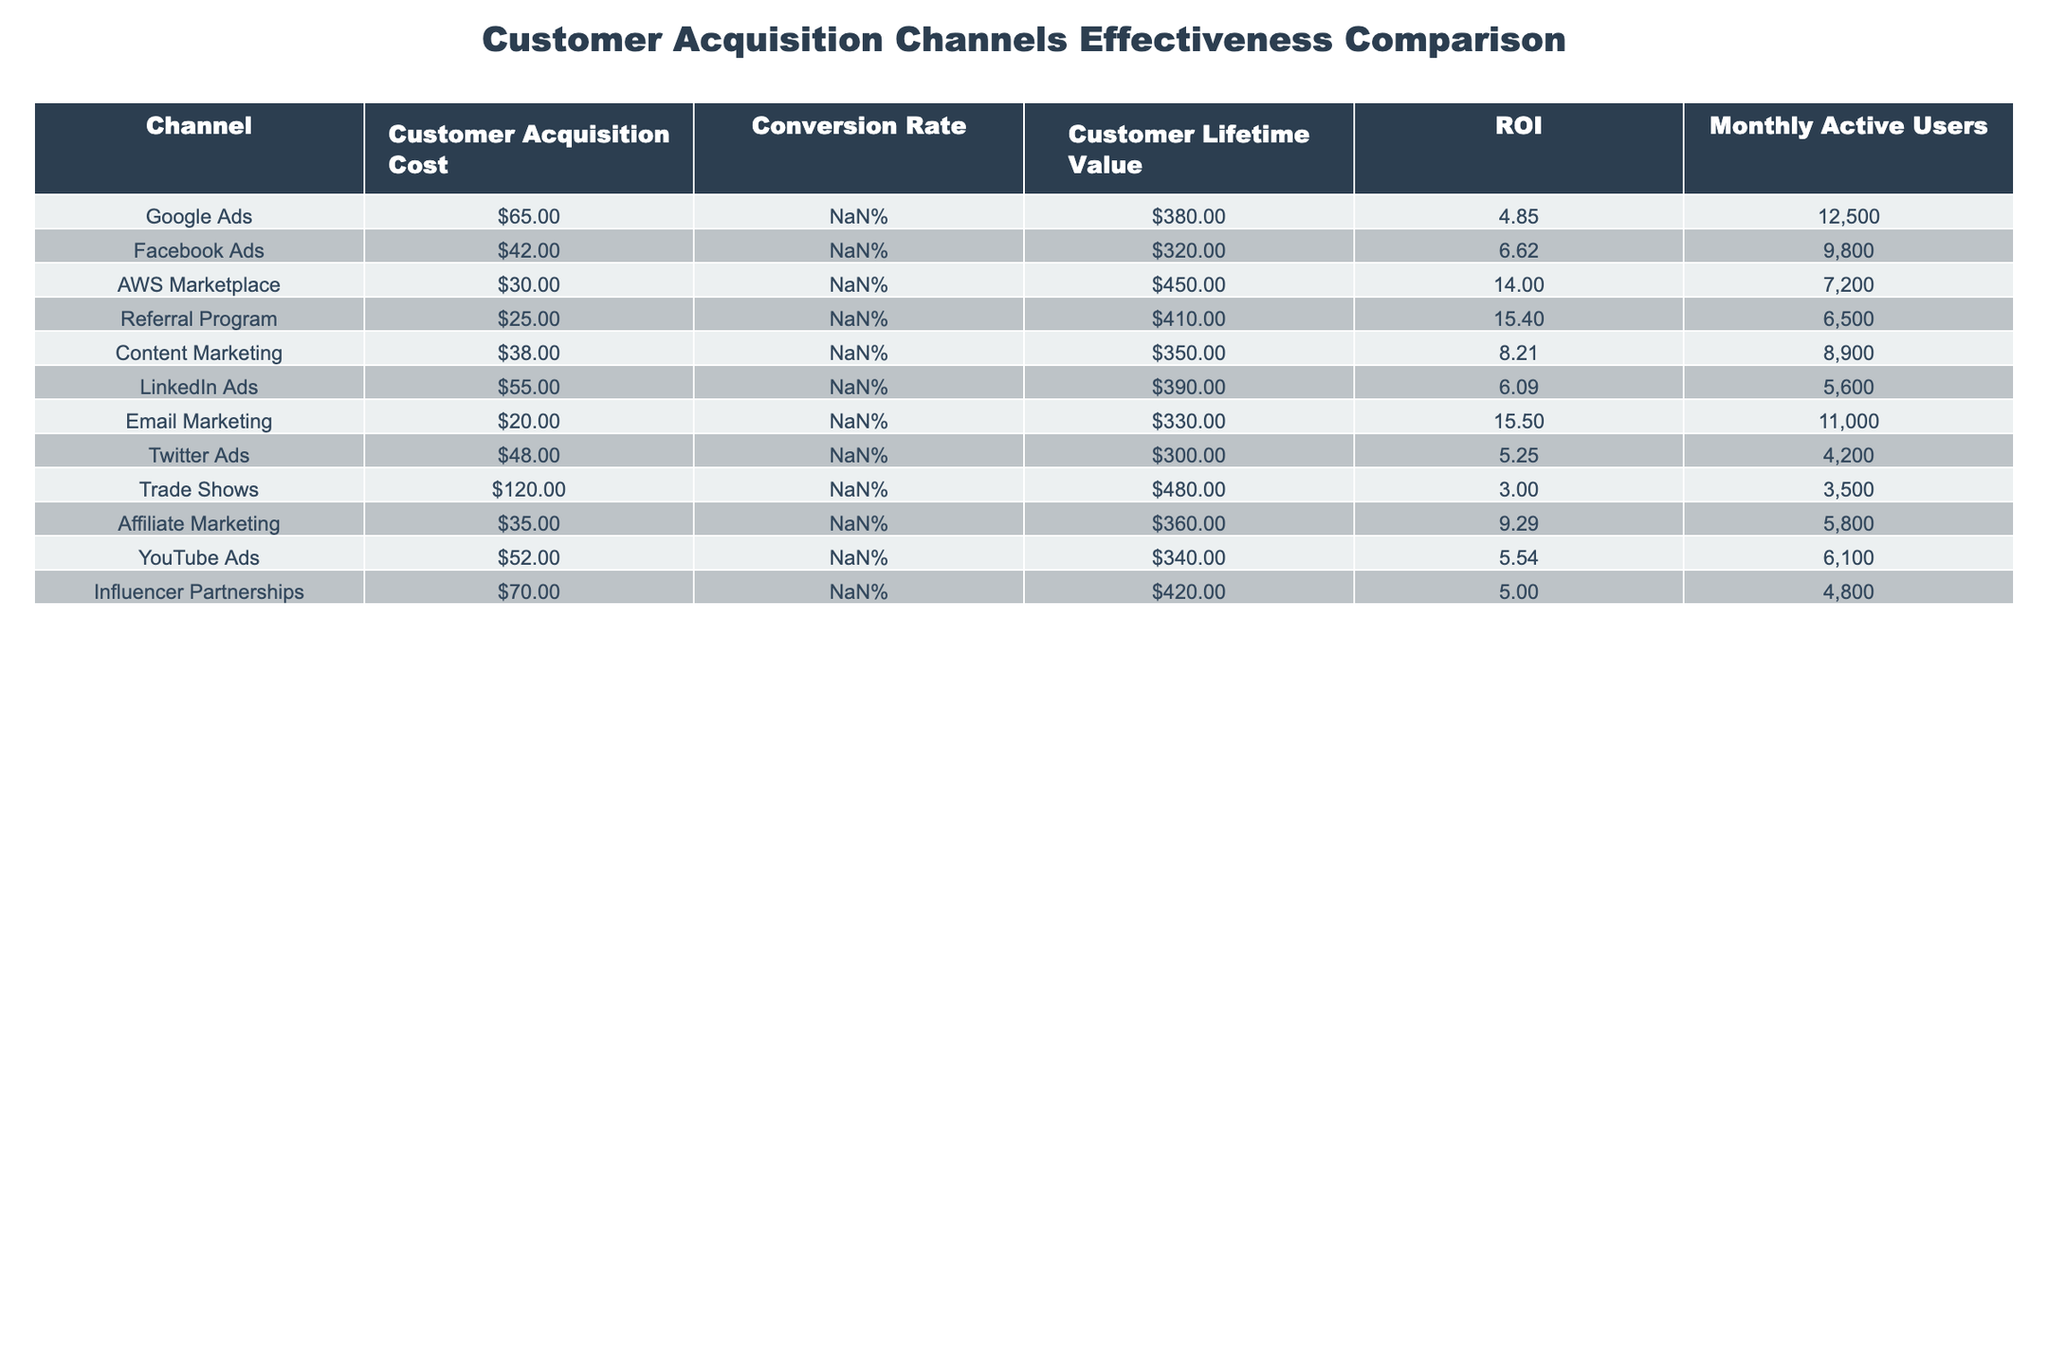What is the Customer Acquisition Cost for the Referral Program? The Customer Acquisition Cost for the Referral Program is listed directly in the table under the respective column, which shows a value of 25.
Answer: 25 Which customer acquisition channel has the highest Conversion Rate? The highest Conversion Rate can be found by comparing the values in the "Conversion Rate" column. The Referral Program has the highest rate at 5.2%.
Answer: 5.2% What is the ROI for Email Marketing? The ROI for Email Marketing is indicated in the table under the ROI column, showing a value of 15.50.
Answer: 15.50 What is the difference in Customer Lifetime Value between Google Ads and AWS Marketplace? The Customer Lifetime Value for Google Ads is 380 and for AWS Marketplace it is 450. The difference is calculated by subtracting: 450 - 380 = 70.
Answer: 70 Is the Customer Acquisition Cost for Trade Shows higher than that for YouTube Ads? The Customer Acquisition Cost for Trade Shows is 120, while for YouTube Ads it is 52. Since 120 is greater than 52, the statement is true.
Answer: Yes Which channel has the lowest ROI and what is it? By reviewing the ROI column, Trade Shows show the lowest ROI at 3.00.
Answer: 3.00 What is the average Customer Acquisition Cost for all channels? The total Customer Acquisition Cost of all channels is calculated by summing the individual costs: (65 + 42 + 30 + 25 + 38 + 55 + 20 + 48 + 120 + 35 + 52 + 70) =  570. There are 12 channels, so the average is 570 / 12 = 47.50.
Answer: 47.50 Which acquisition channel has the highest Monthly Active Users and what is the value? By inspecting the "Monthly Active Users" column, Google Ads has the highest number with 12,500 users.
Answer: 12,500 If we were to combine the ROI of both Facebook Ads and Affiliate Marketing, what would the total be? Facebook Ads has an ROI of 6.62 and Affiliate Marketing has an ROI of 9.29. Adding these values together gives a total of 6.62 + 9.29 = 15.91.
Answer: 15.91 Which channel has a higher Customer Lifetime Value, Email Marketing or Content Marketing? The Customer Lifetime Value for Email Marketing is 330 and for Content Marketing, it is 350. After comparison, Content Marketing has a higher lifetime value.
Answer: Content Marketing 